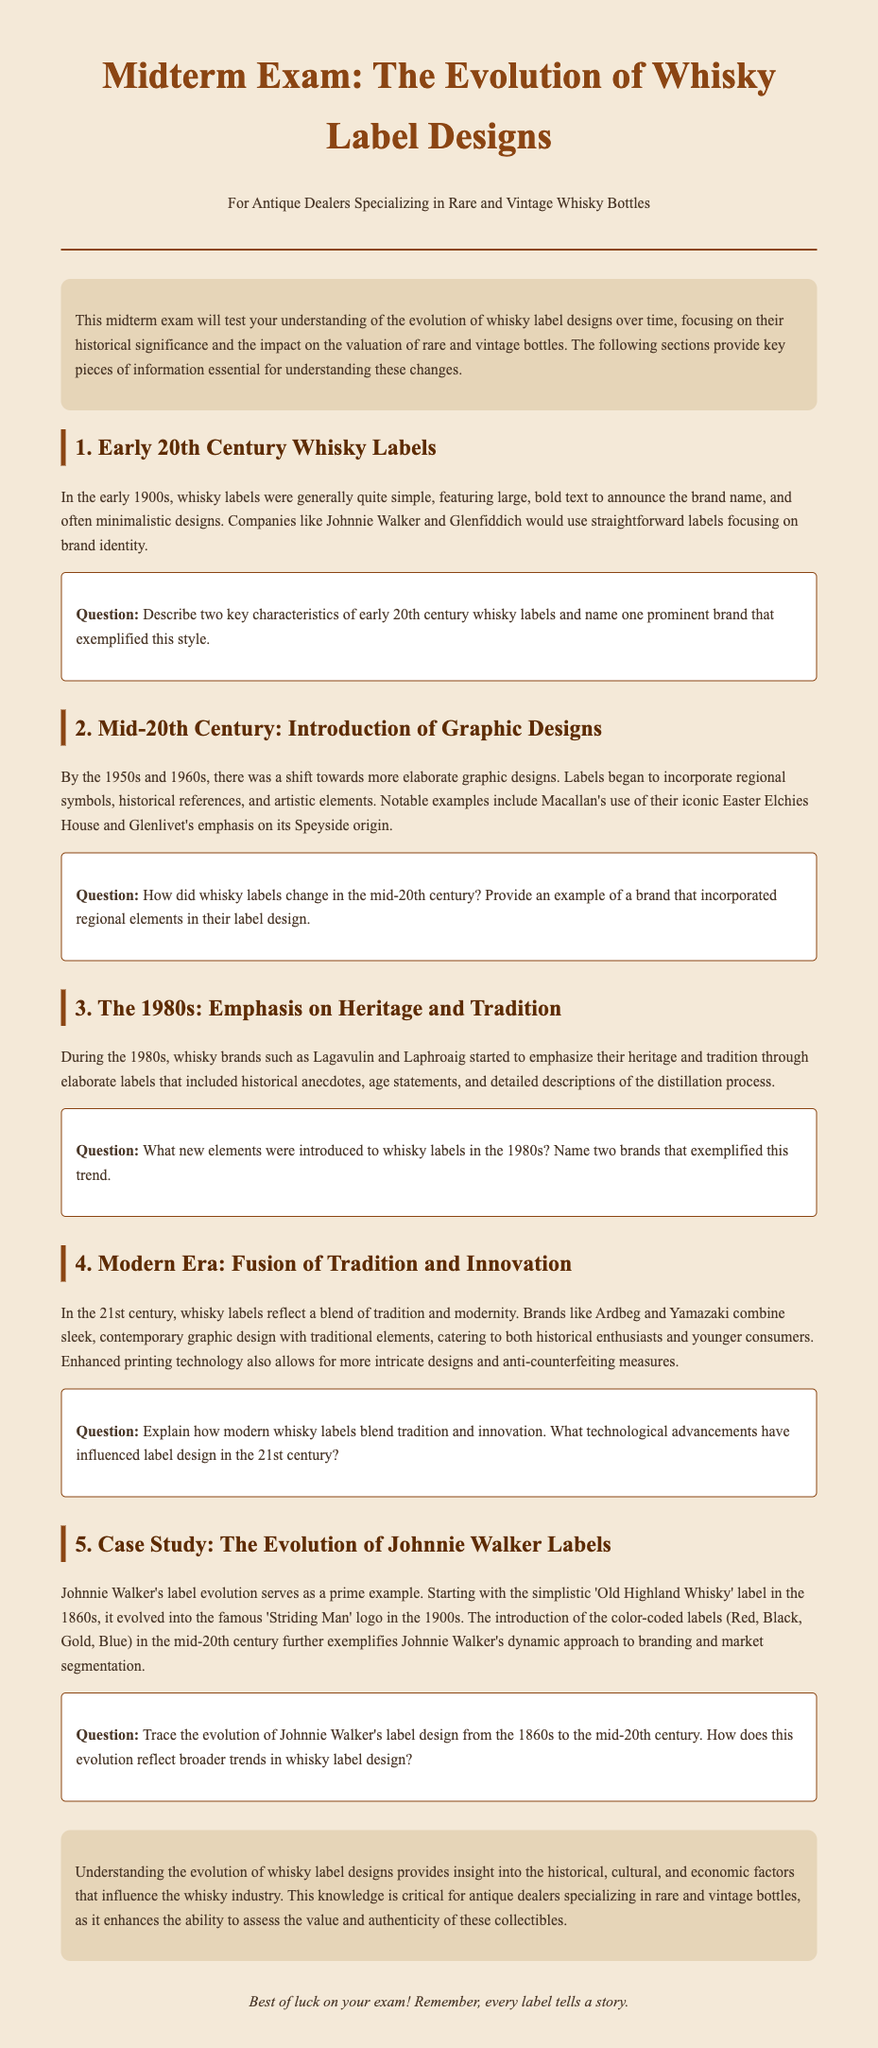What are two key characteristics of early 20th century whisky labels? The document states that early 20th century whisky labels featured large, bold text and minimalistic designs.
Answer: large, bold text; minimalistic designs Name one prominent brand that exemplified early 20th century whisky label design. The document mentions Johnnie Walker and Glenfiddich as examples of this style.
Answer: Johnnie Walker What shift occurred in whisky labels during the mid-20th century? The document notes a transition to more elaborate graphic designs, incorporating regional symbols and artistic elements.
Answer: elaborate graphic designs Which brand emphasized regional elements in their label design in the mid-20th century? The document highlights Macallan as a notable example of a brand that incorporated regional symbols.
Answer: Macallan What new elements were introduced to whisky labels in the 1980s? The document mentions that elaborate labels included historical anecdotes, age statements, and detailed descriptions of the distillation process.
Answer: historical anecdotes; age statements; detailed descriptions Name two brands that exemplified the trend of heritage emphasis in the 1980s. The document specifies Lagavulin and Laphroaig as examples of brands focusing on their heritage during this decade.
Answer: Lagavulin; Laphroaig How do modern whisky labels blend tradition and innovation? According to the document, modern whisky labels combine sleek, contemporary graphic design with traditional elements.
Answer: sleek, contemporary graphic design; traditional elements What technological advancements have influenced label design in the 21st century? The document notes enhanced printing technology enabling more intricate designs and anti-counterfeiting measures as advancements.
Answer: enhanced printing technology What was the original label name of Johnnie Walker whisky in the 1860s? The document states the original label was called 'Old Highland Whisky'.
Answer: Old Highland Whisky What does Johnnie Walker's color-coded labels represent in the mid-20th century? The document suggests that the color-coded labels exemplified Johnnie Walker's dynamic approach to branding and market segmentation.
Answer: dynamic approach to branding and market segmentation 